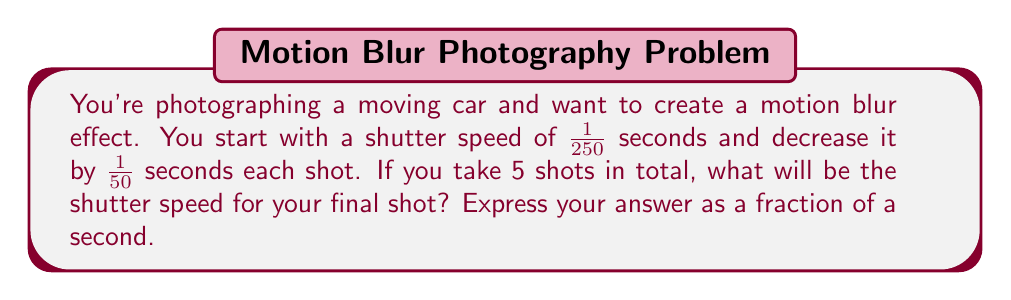Can you answer this question? Let's approach this step-by-step using an arithmetic sequence:

1) The initial term (first shutter speed): $a_1 = \frac{1}{250}$ seconds

2) The common difference (decrease in shutter speed each shot): $d = \frac{1}{50}$ seconds

3) We need to find the 5th term in this sequence.

4) The formula for the nth term of an arithmetic sequence is:
   $a_n = a_1 + (n-1)d$

5) Substituting our values:
   $a_5 = \frac{1}{250} + (5-1) \cdot \frac{1}{50}$

6) Simplify:
   $a_5 = \frac{1}{250} + \frac{4}{50}$

7) Find a common denominator:
   $a_5 = \frac{1}{250} + \frac{20}{250} = \frac{21}{250}$

8) Simplify the fraction:
   $a_5 = \frac{21}{250} = \frac{21 \div 1}{250 \div 1} = \frac{21}{250}$

Therefore, the shutter speed for the final (5th) shot will be $\frac{21}{250}$ seconds.
Answer: $\frac{21}{250}$ seconds 